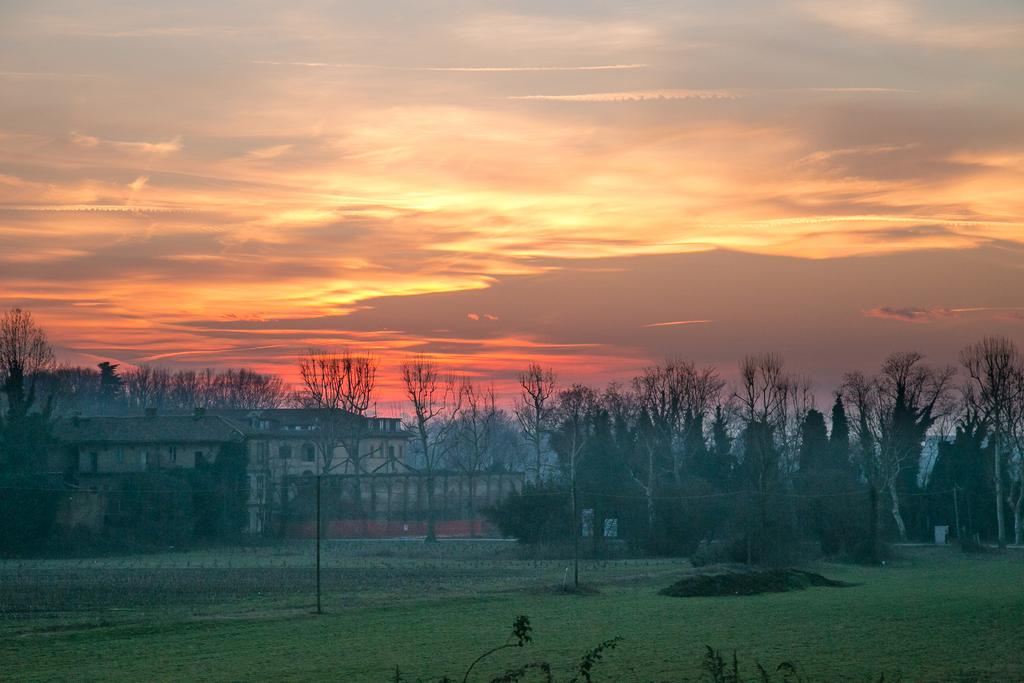What type of vegetation is present in the image? There are trees in the image. What type of structures can be seen in the image? There are buildings in the image. What is covering the ground in the image? There is grass on the ground in the image. What can be seen in the sky in the background of the image? There are clouds in the sky in the background of the image. What type of belief is represented by the snake in the image? There is no snake present in the image, so it is not possible to determine what belief might be represented. What sound can be heard coming from the clouds in the image? There is no sound present in the image, as it is a still image and does not include any audio. 